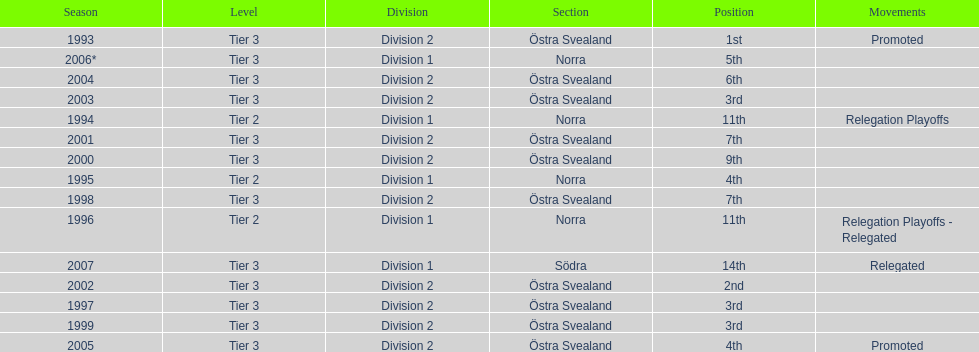During which season was visby if gute fk the winner of division 2 tier 3? 1993. 